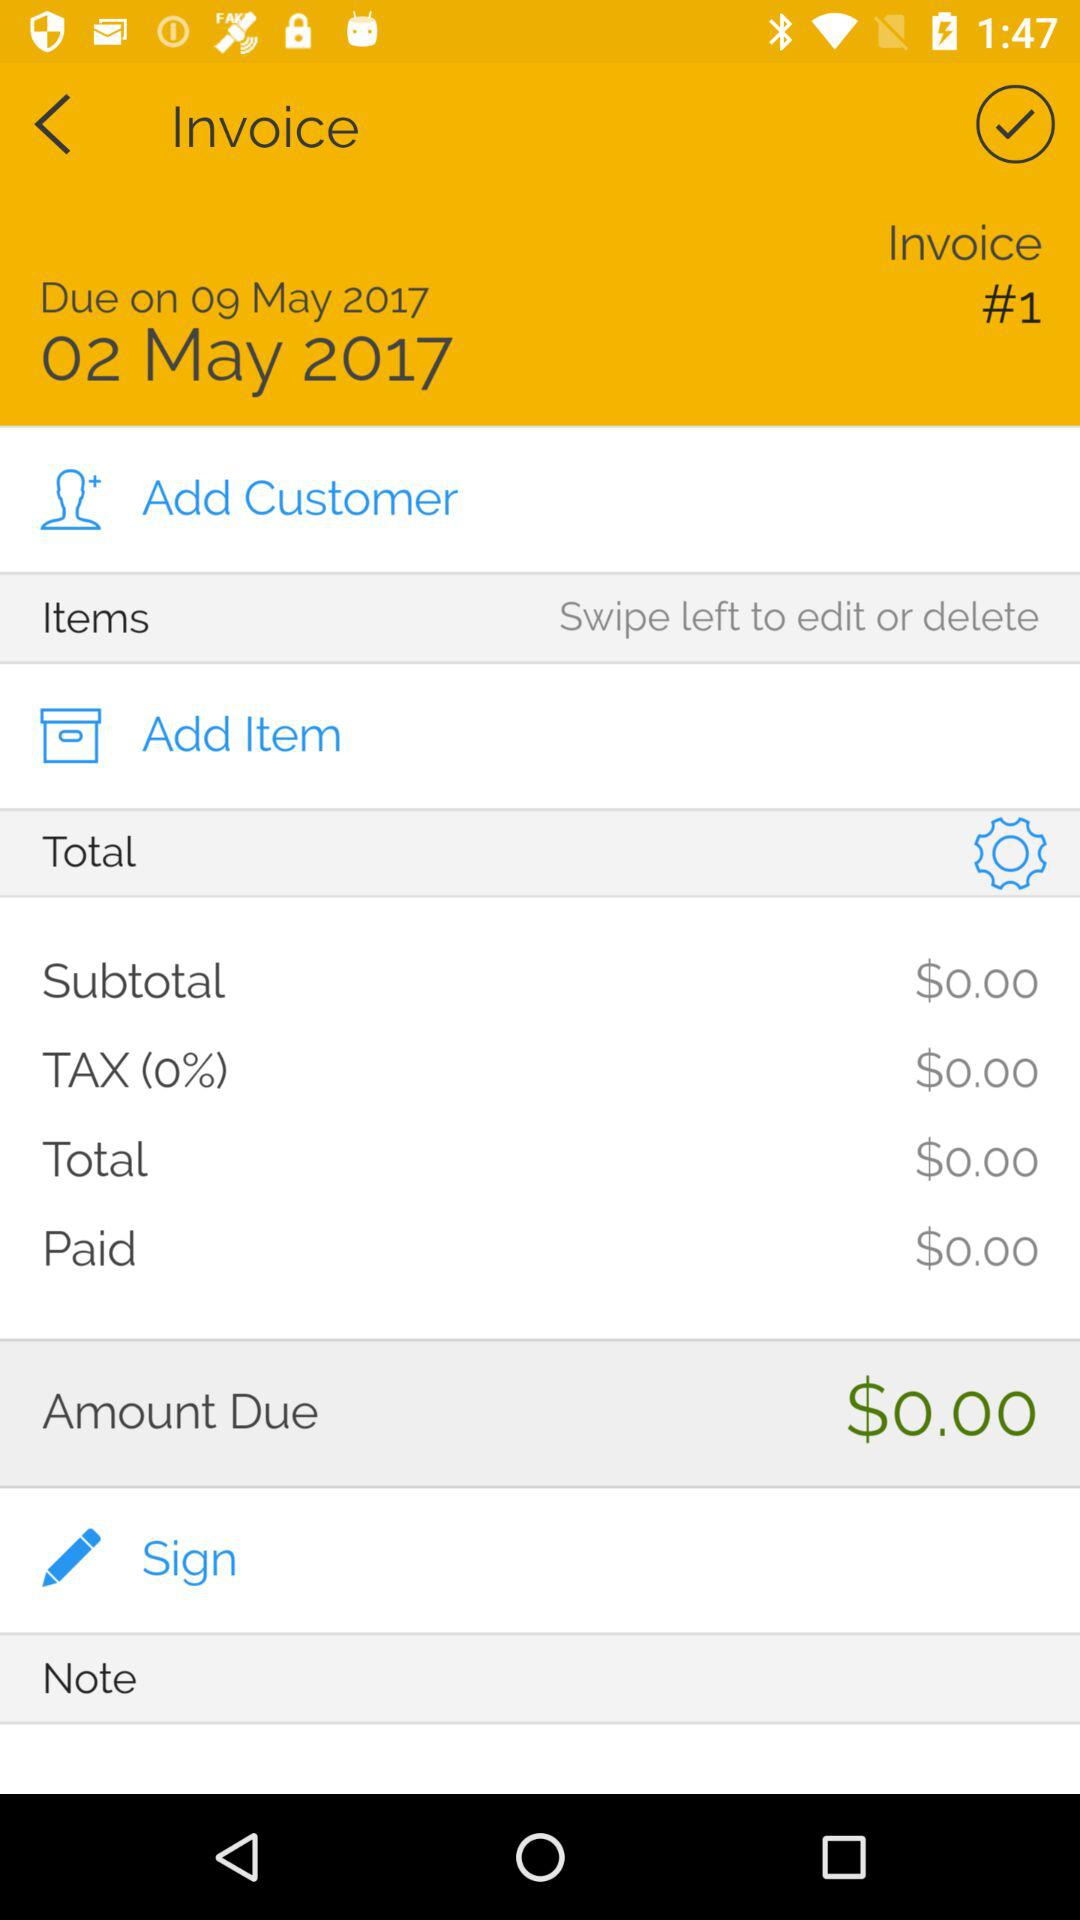How much is the total amount due?
Answer the question using a single word or phrase. $0.00 